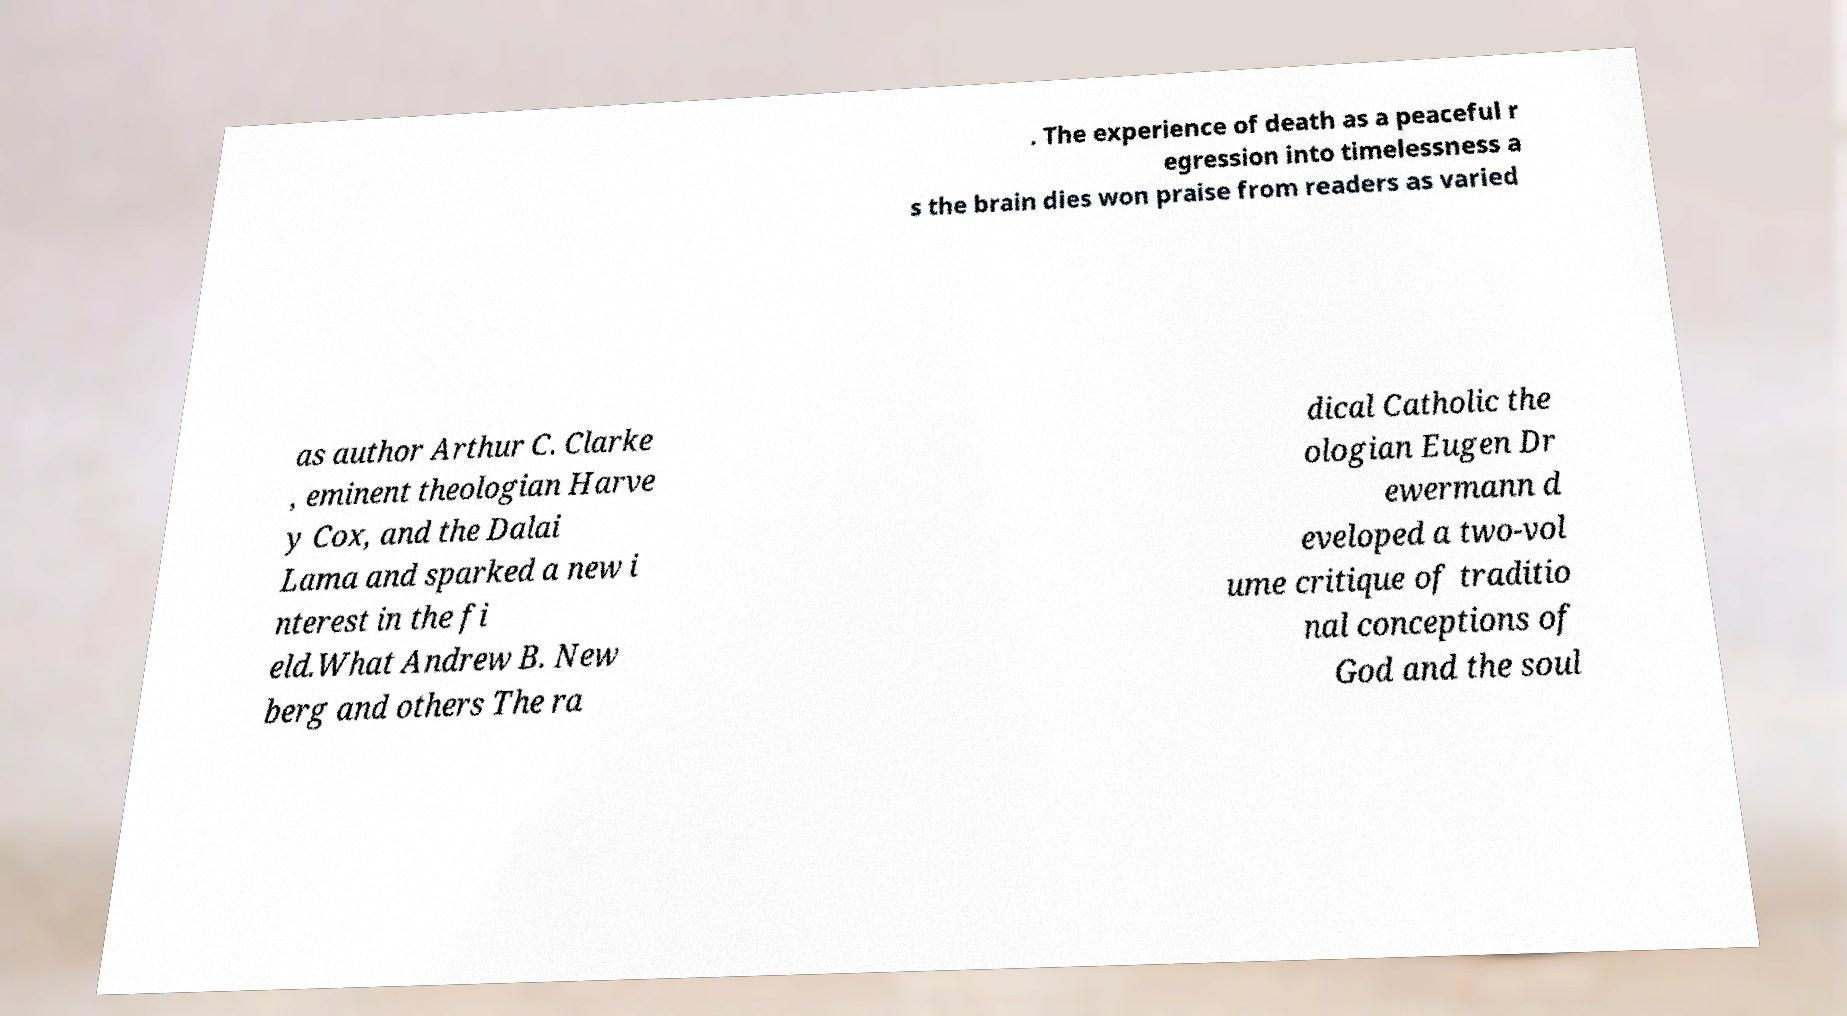Could you assist in decoding the text presented in this image and type it out clearly? . The experience of death as a peaceful r egression into timelessness a s the brain dies won praise from readers as varied as author Arthur C. Clarke , eminent theologian Harve y Cox, and the Dalai Lama and sparked a new i nterest in the fi eld.What Andrew B. New berg and others The ra dical Catholic the ologian Eugen Dr ewermann d eveloped a two-vol ume critique of traditio nal conceptions of God and the soul 